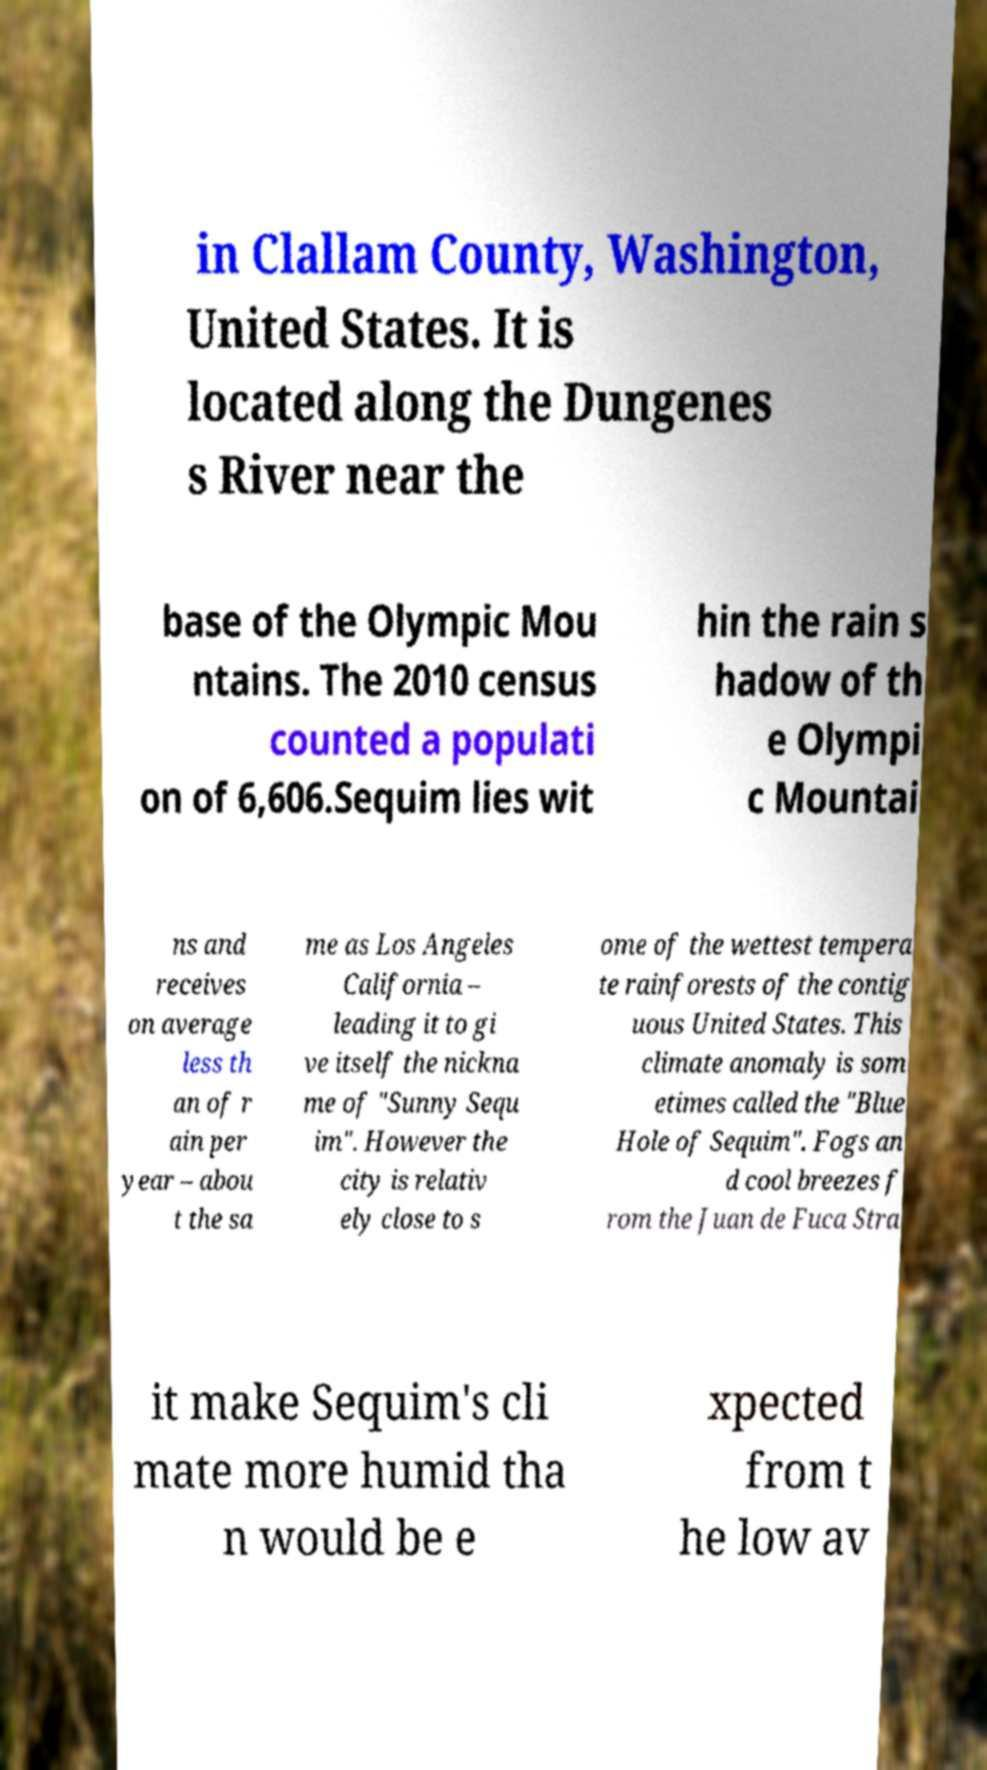For documentation purposes, I need the text within this image transcribed. Could you provide that? in Clallam County, Washington, United States. It is located along the Dungenes s River near the base of the Olympic Mou ntains. The 2010 census counted a populati on of 6,606.Sequim lies wit hin the rain s hadow of th e Olympi c Mountai ns and receives on average less th an of r ain per year – abou t the sa me as Los Angeles California – leading it to gi ve itself the nickna me of "Sunny Sequ im". However the city is relativ ely close to s ome of the wettest tempera te rainforests of the contig uous United States. This climate anomaly is som etimes called the "Blue Hole of Sequim". Fogs an d cool breezes f rom the Juan de Fuca Stra it make Sequim's cli mate more humid tha n would be e xpected from t he low av 